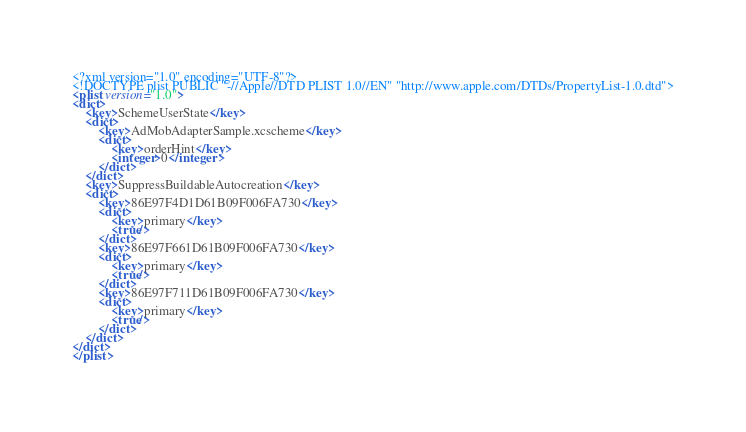<code> <loc_0><loc_0><loc_500><loc_500><_XML_><?xml version="1.0" encoding="UTF-8"?>
<!DOCTYPE plist PUBLIC "-//Apple//DTD PLIST 1.0//EN" "http://www.apple.com/DTDs/PropertyList-1.0.dtd">
<plist version="1.0">
<dict>
	<key>SchemeUserState</key>
	<dict>
		<key>AdMobAdapterSample.xcscheme</key>
		<dict>
			<key>orderHint</key>
			<integer>0</integer>
		</dict>
	</dict>
	<key>SuppressBuildableAutocreation</key>
	<dict>
		<key>86E97F4D1D61B09F006FA730</key>
		<dict>
			<key>primary</key>
			<true/>
		</dict>
		<key>86E97F661D61B09F006FA730</key>
		<dict>
			<key>primary</key>
			<true/>
		</dict>
		<key>86E97F711D61B09F006FA730</key>
		<dict>
			<key>primary</key>
			<true/>
		</dict>
	</dict>
</dict>
</plist>
</code> 